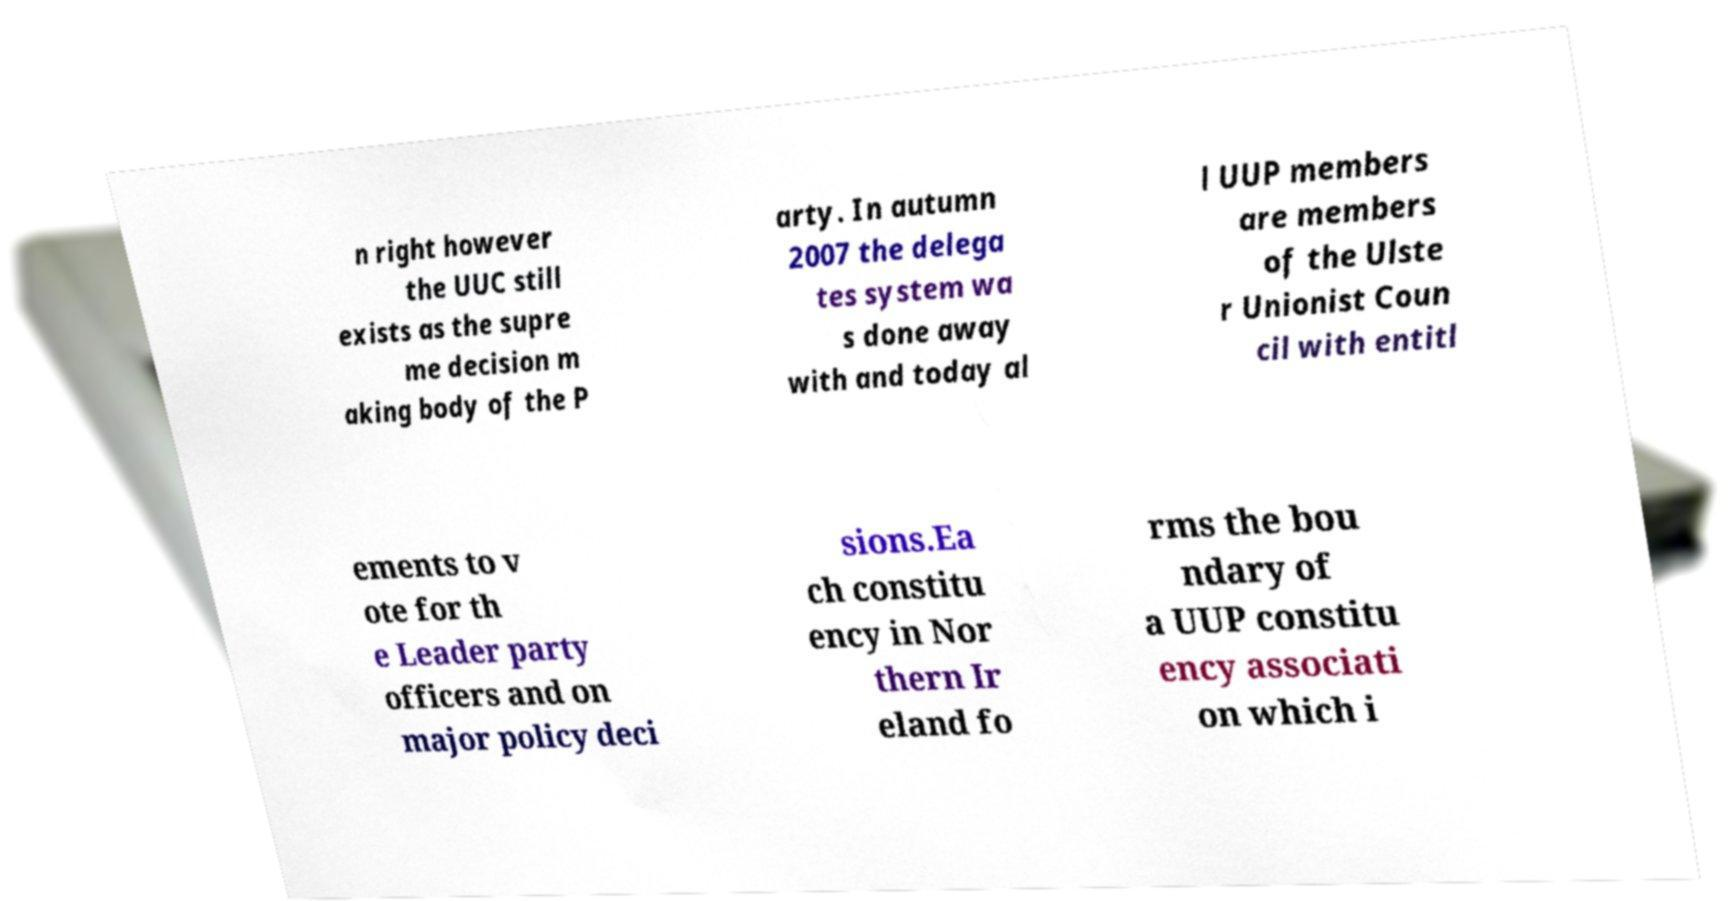Could you extract and type out the text from this image? n right however the UUC still exists as the supre me decision m aking body of the P arty. In autumn 2007 the delega tes system wa s done away with and today al l UUP members are members of the Ulste r Unionist Coun cil with entitl ements to v ote for th e Leader party officers and on major policy deci sions.Ea ch constitu ency in Nor thern Ir eland fo rms the bou ndary of a UUP constitu ency associati on which i 